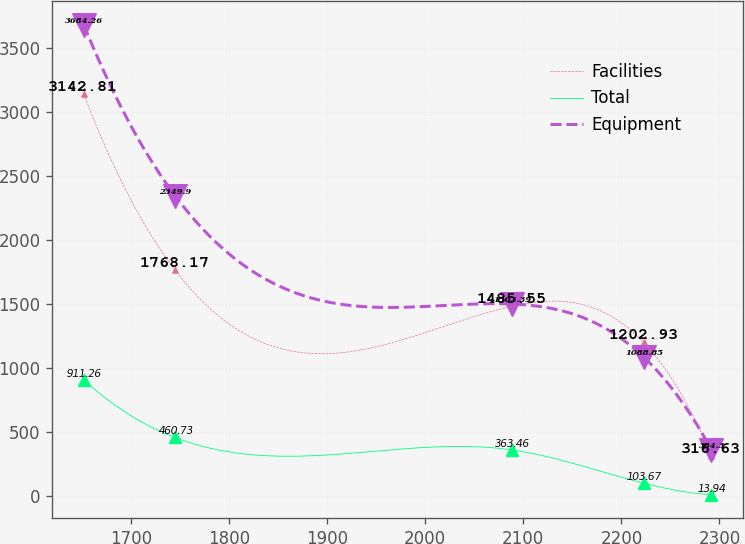Convert chart to OTSL. <chart><loc_0><loc_0><loc_500><loc_500><line_chart><ecel><fcel>Facilities<fcel>Total<fcel>Equipment<nl><fcel>1651.73<fcel>3142.81<fcel>911.26<fcel>3684.26<nl><fcel>1744.8<fcel>1768.17<fcel>460.73<fcel>2349.9<nl><fcel>2088.61<fcel>1485.55<fcel>363.46<fcel>1503.39<nl><fcel>2222.79<fcel>1202.93<fcel>103.67<fcel>1088.85<nl><fcel>2291.87<fcel>316.63<fcel>13.94<fcel>364.3<nl></chart> 